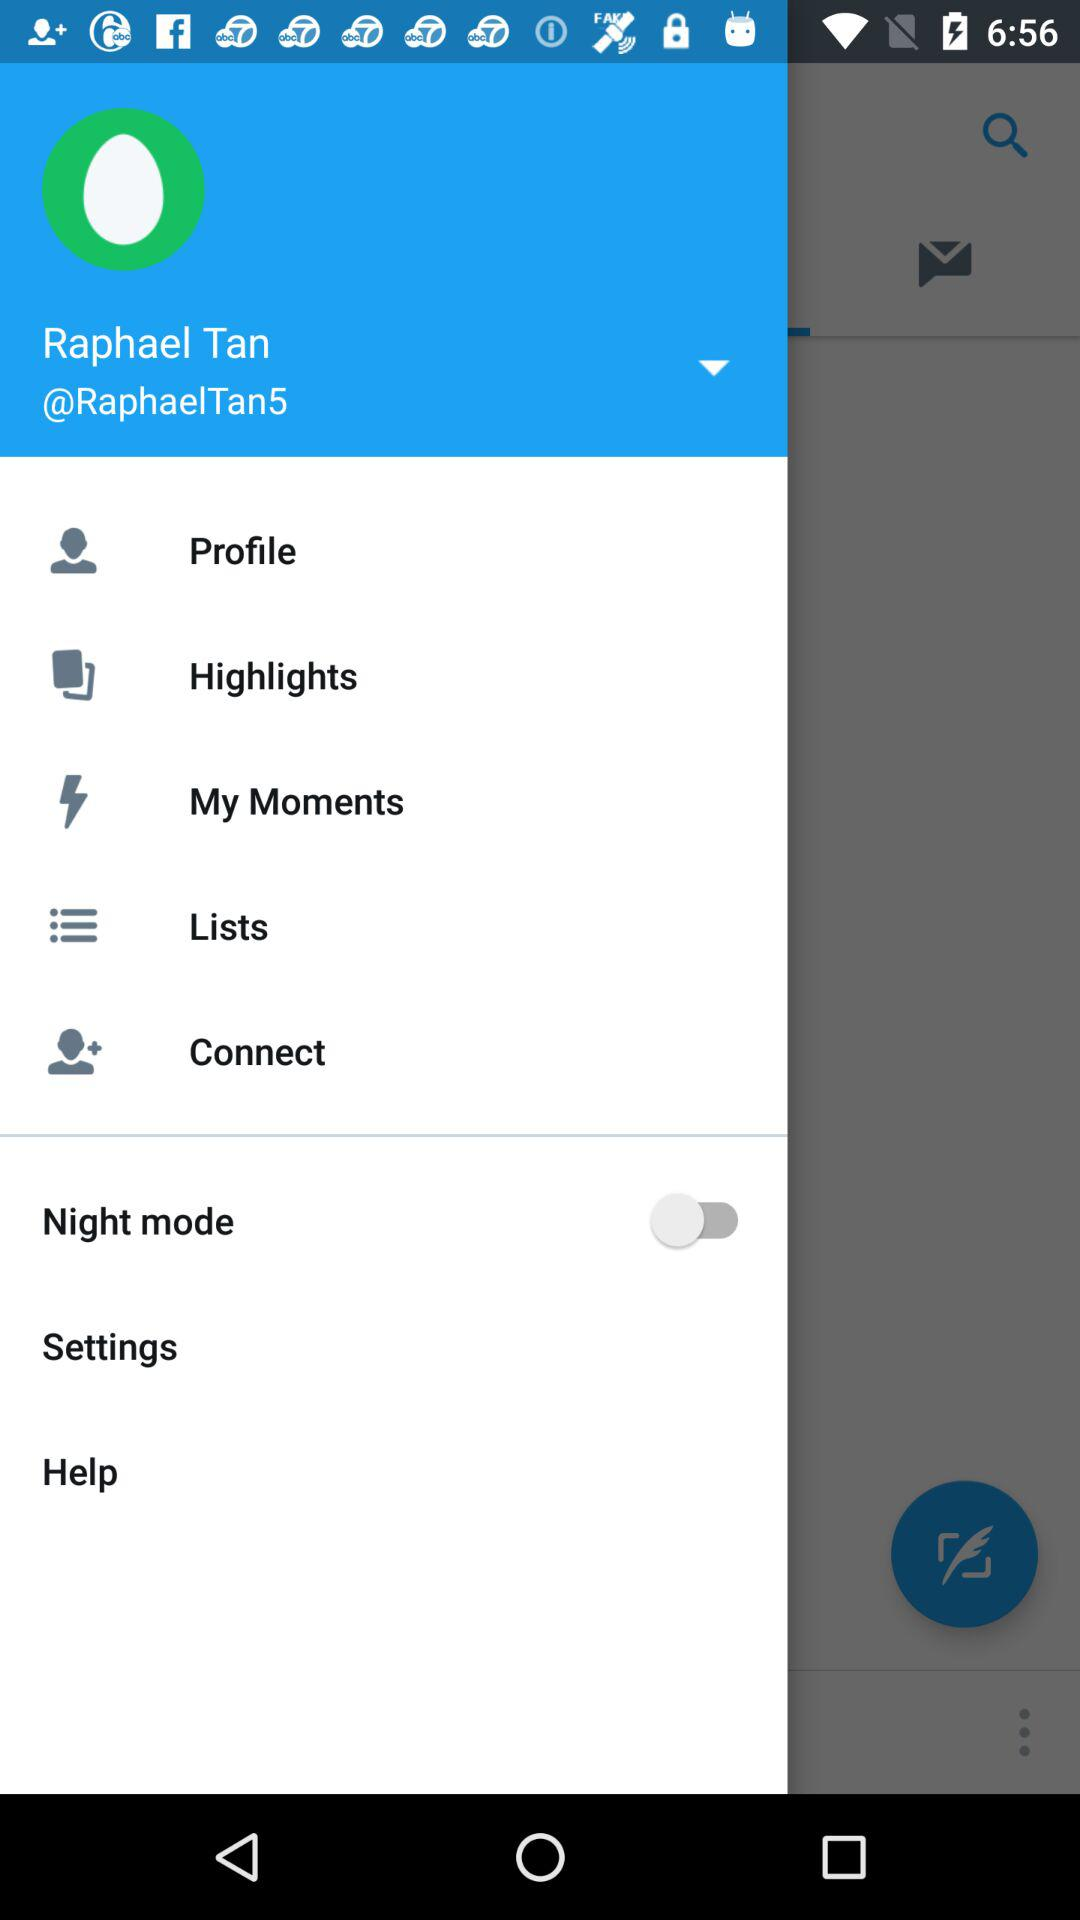What is the status of "Night mode"? The status is "off". 